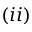Convert formula to latex. <formula><loc_0><loc_0><loc_500><loc_500>( i i )</formula> 